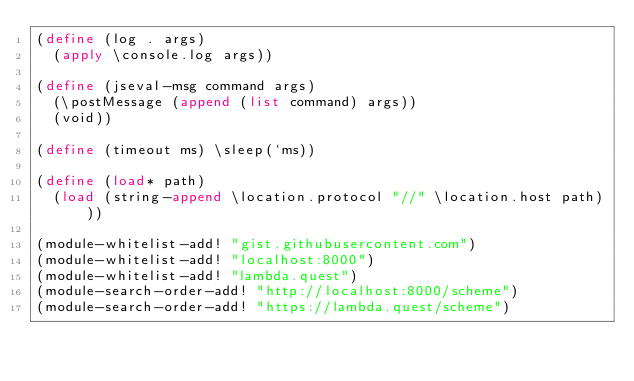<code> <loc_0><loc_0><loc_500><loc_500><_Scheme_>(define (log . args)
  (apply \console.log args))

(define (jseval-msg command args)
  (\postMessage (append (list command) args))
  (void))

(define (timeout ms) \sleep(`ms))

(define (load* path)
  (load (string-append \location.protocol "//" \location.host path)))

(module-whitelist-add! "gist.githubusercontent.com")
(module-whitelist-add! "localhost:8000")
(module-whitelist-add! "lambda.quest")
(module-search-order-add! "http://localhost:8000/scheme")
(module-search-order-add! "https://lambda.quest/scheme")
</code> 